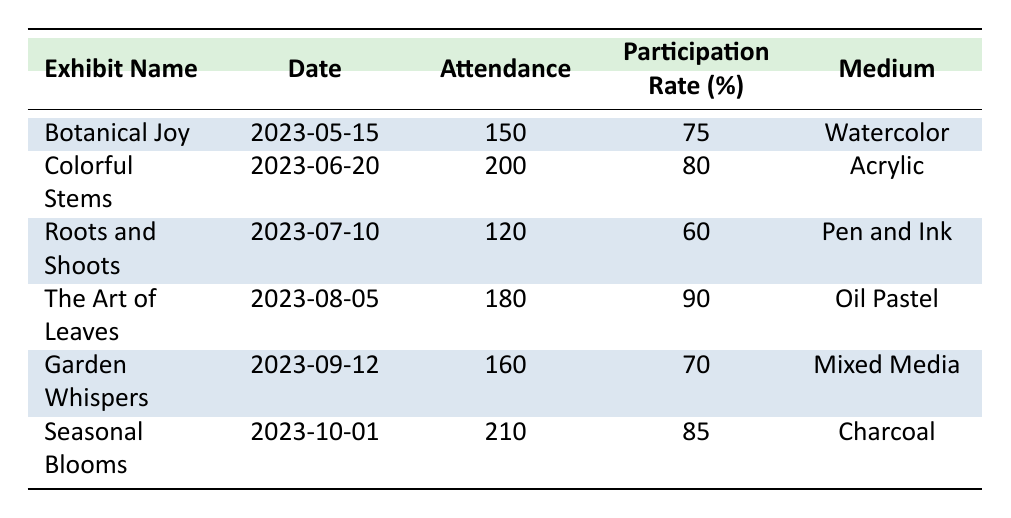What was the attendance at the exhibit "Garden Whispers"? In the table, I can find the row for "Garden Whispers" which indicates that the attendance was 160.
Answer: 160 Which exhibit had the highest participation rate? By looking through the participation rates in the table, "The Art of Leaves" has the highest rate at 90%.
Answer: 90% How many exhibitors were there at the "Roots and Shoots" exhibit? The row for "Roots and Shoots" shows that there were 4 exhibitors.
Answer: 4 What is the total attendance for all exhibits? I will sum the attendance numbers: 150 + 200 + 120 + 180 + 160 + 210 = 1020.
Answer: 1020 Is the participation rate for "Colorful Stems" higher than that of "Botanical Joy"? "Colorful Stems" has a participation rate of 80%, while "Botanical Joy" has 75%. Yes, it is higher.
Answer: Yes What was the average attendance across all exhibits? The total attendance is 1020, and there are 6 exhibits, so I divide 1020 by 6: 1020 / 6 = 170.
Answer: 170 What was the medium used for the exhibit with the lowest participation rate? The lowest participation rate is for "Roots and Shoots" at 60%, and its medium is Pen and Ink.
Answer: Pen and Ink Which exhibit had a higher attendance: "Seasonal Blooms" or "The Art of Leaves"? "Seasonal Blooms" had 210 attendees, while "The Art of Leaves" had 180 attendees. So, "Seasonal Blooms" had the higher attendance.
Answer: Seasonal Blooms Was there an exhibit that had more than 180 attendees and an 80% participation rate or higher? The exhibits "Colorful Stems" and "Seasonal Blooms" both had over 180 attendees and participation rates of 80% and 85%, respectively. So, yes, there were exhibits that meet these criteria.
Answer: Yes What is the difference in participation rates between "Botanical Joy" and "Garden Whispers"? "Botanical Joy" has a participation rate of 75%, while "Garden Whispers" has 70%. The difference is 75 - 70 = 5.
Answer: 5 